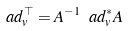<formula> <loc_0><loc_0><loc_500><loc_500>\ a d _ { v } ^ { \top } = A ^ { - 1 } \ a d ^ { * } _ { v } A</formula> 